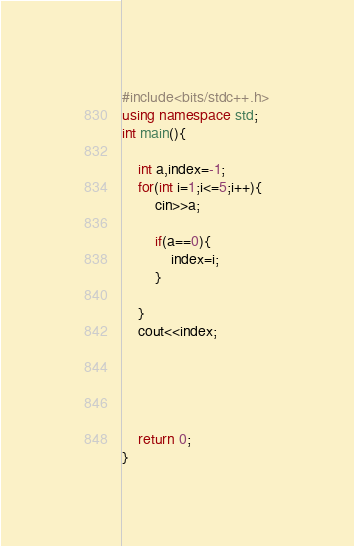<code> <loc_0><loc_0><loc_500><loc_500><_C++_>#include<bits/stdc++.h>
using namespace std;
int main(){
    
    int a,index=-1;
    for(int i=1;i<=5;i++){
        cin>>a;
        
        if(a==0){
            index=i;
        }

    }
    cout<<index;

    



    return 0;
}</code> 